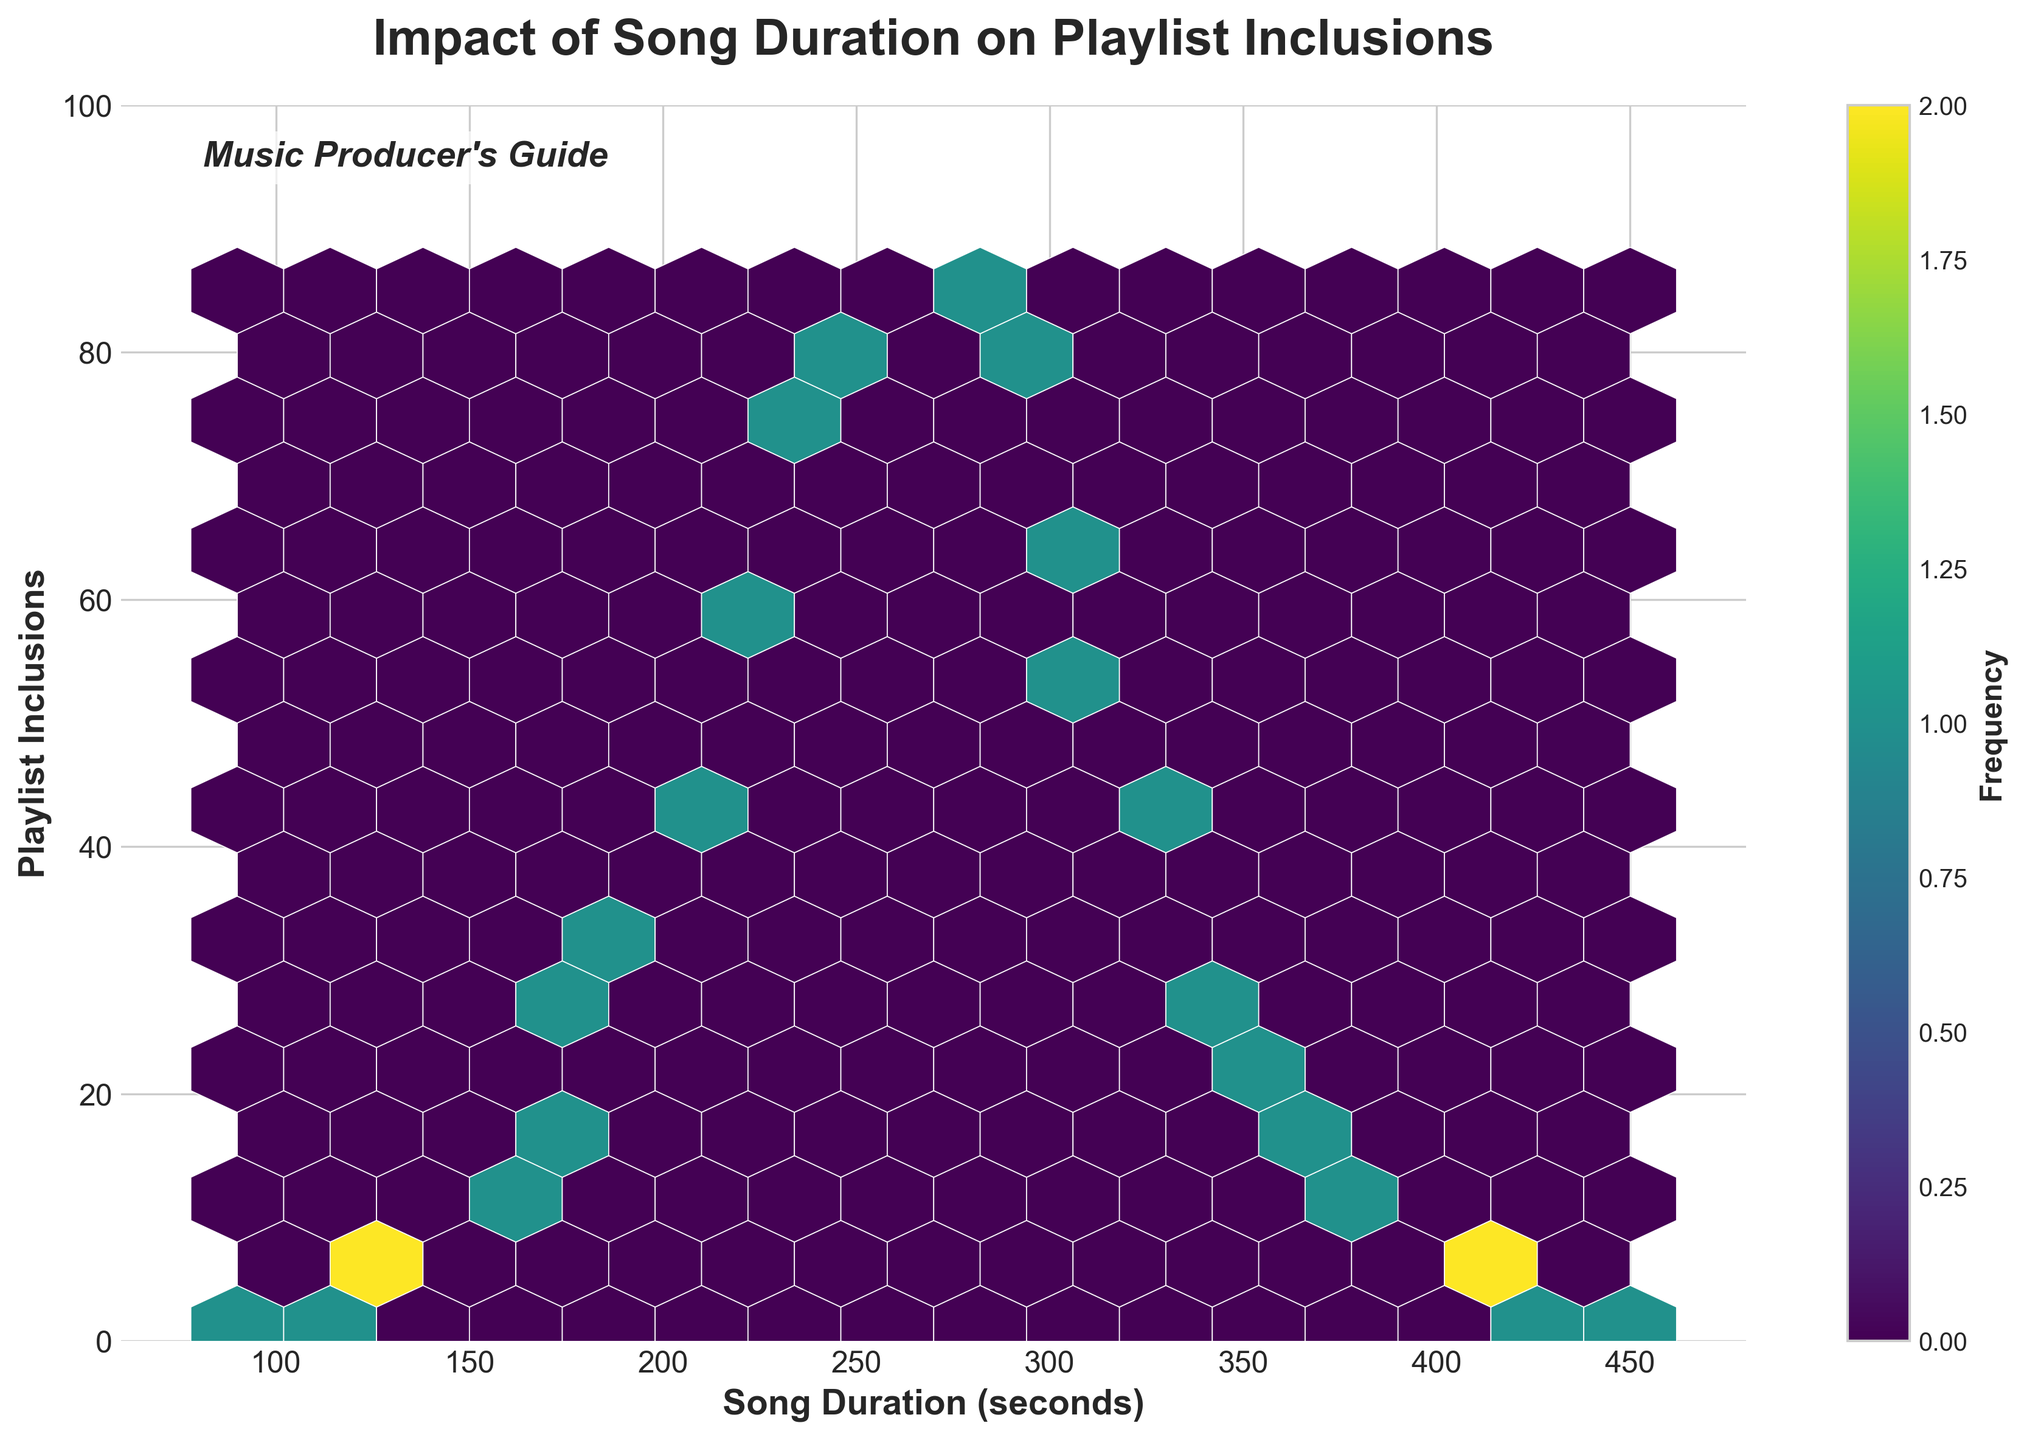What is the title of the plot? The title is located at the top of the plot and clearly states the focus of the visualization.
Answer: Impact of Song Duration on Playlist Inclusions What does the x-axis represent in the plot? The label on the x-axis shows what variable is being measured along the horizontal axis.
Answer: Song Duration (seconds) What is the range of the y-axis in the plot? Observing the y-axis values, we can see the range from the smallest to the largest value.
Answer: 0 to 100 How many hexbin cells are there with the highest frequency? The plot uses a color map to represent the frequency of data points in each hexbin cell. The highest frequency is represented by the darkest color. Counting these cells will give the answer.
Answer: 1 In which duration range do you observe the highest playlist inclusions? Looking at where the highest (darkest) hexbin cell is located on the x-axis gives the approximate range of song durations.
Answer: 240 to 270 seconds Comparing songs of 210 seconds and 360 seconds, which has more playlist inclusions? By finding the hexbin cells corresponding to these durations and checking their frequencies, we can determine which has more playlist inclusions.
Answer: 210 seconds Which song duration range appears to have the least playlist inclusions? Observing the lightest (least colored) hexbin cells on the plot, we can identify the duration range with the minimal playlist inclusions.
Answer: 420 to 450 seconds What general trend can be observed between song duration and playlist inclusions? To determine the trend, observe how the hexbin cells are spread and their color intensity from the left to the right of the plot.
Answer: Inclusions increase with duration up to a point, then decrease How is the frequency information represented in the plot? Checking for any legend or additional elements like color bars that explain how frequency is depicted through color intensity.
Answer: A color bar with the label 'Frequency' What is the color of the hexbin cells indicating the lowest frequency of playlist inclusions? Looking at the plot, identify the color representing the lowest frequency as indicated by the color bar.
Answer: Light yellow 